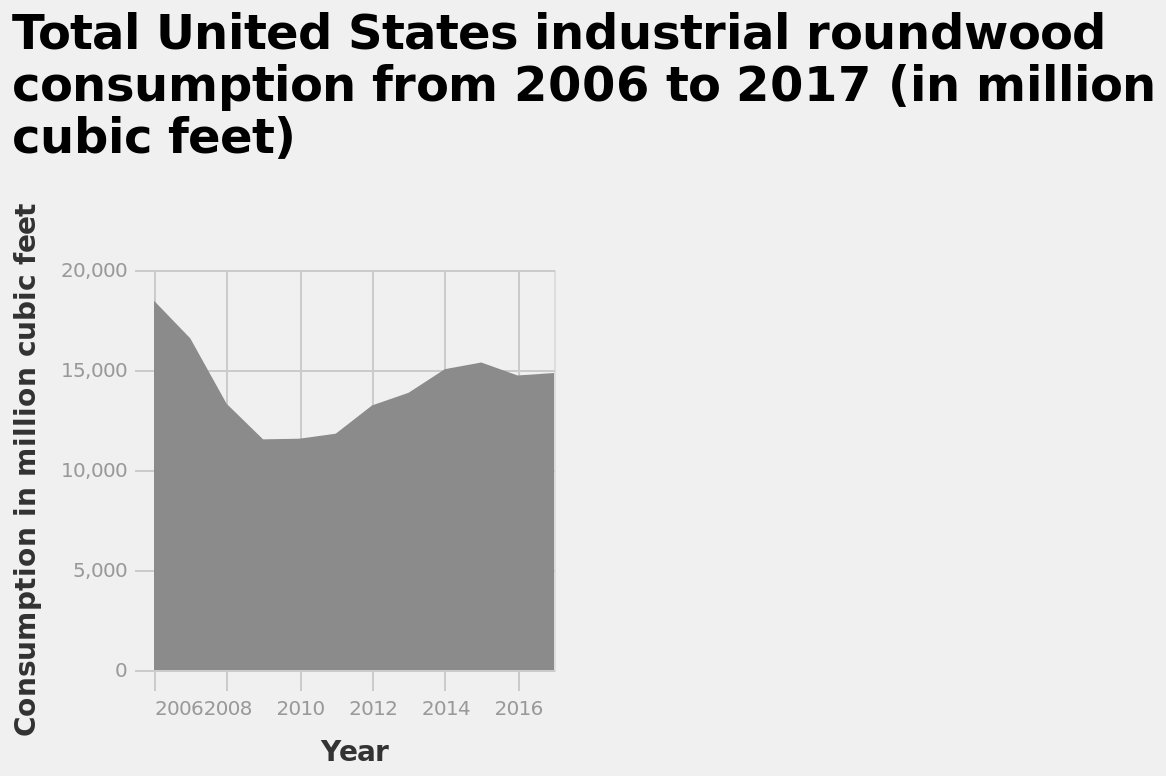<image>
What is the range of the y-axis in the area chart?  The y-axis ranges from 0 to 20,000 million cubic feet. Offer a thorough analysis of the image. Consumption has increased from 2011 and has gradually settled in 2016. What is the highest consumption value shown in the area chart? The highest consumption value shown in the area chart is 20,000 million cubic feet. What is the unit of measurement for the y-axis in the area chart? The y-axis is measured in million cubic feet. Does the y-axis range from 0 to 20 million cubic feet? No. The y-axis ranges from 0 to 20,000 million cubic feet. 